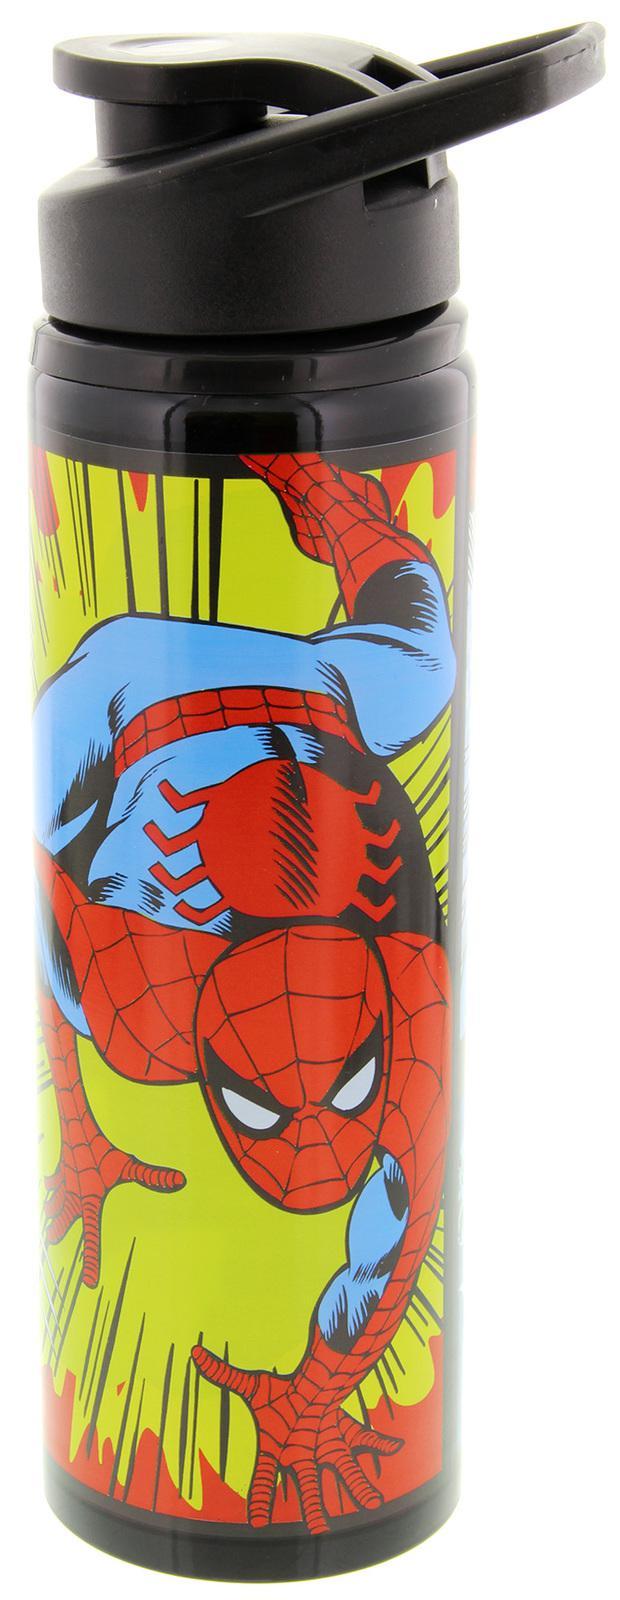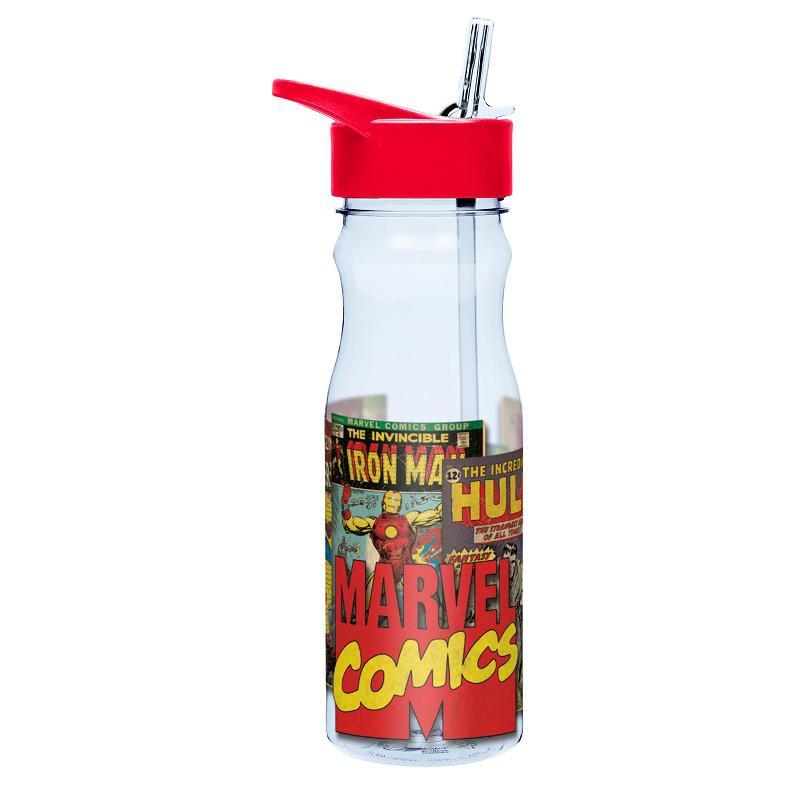The first image is the image on the left, the second image is the image on the right. For the images displayed, is the sentence "There is a bottle with a red lid." factually correct? Answer yes or no. Yes. The first image is the image on the left, the second image is the image on the right. Considering the images on both sides, is "Each water bottle has a black lid, and one water bottle has a grid of at least six square super hero pictures on its front." valid? Answer yes or no. No. 